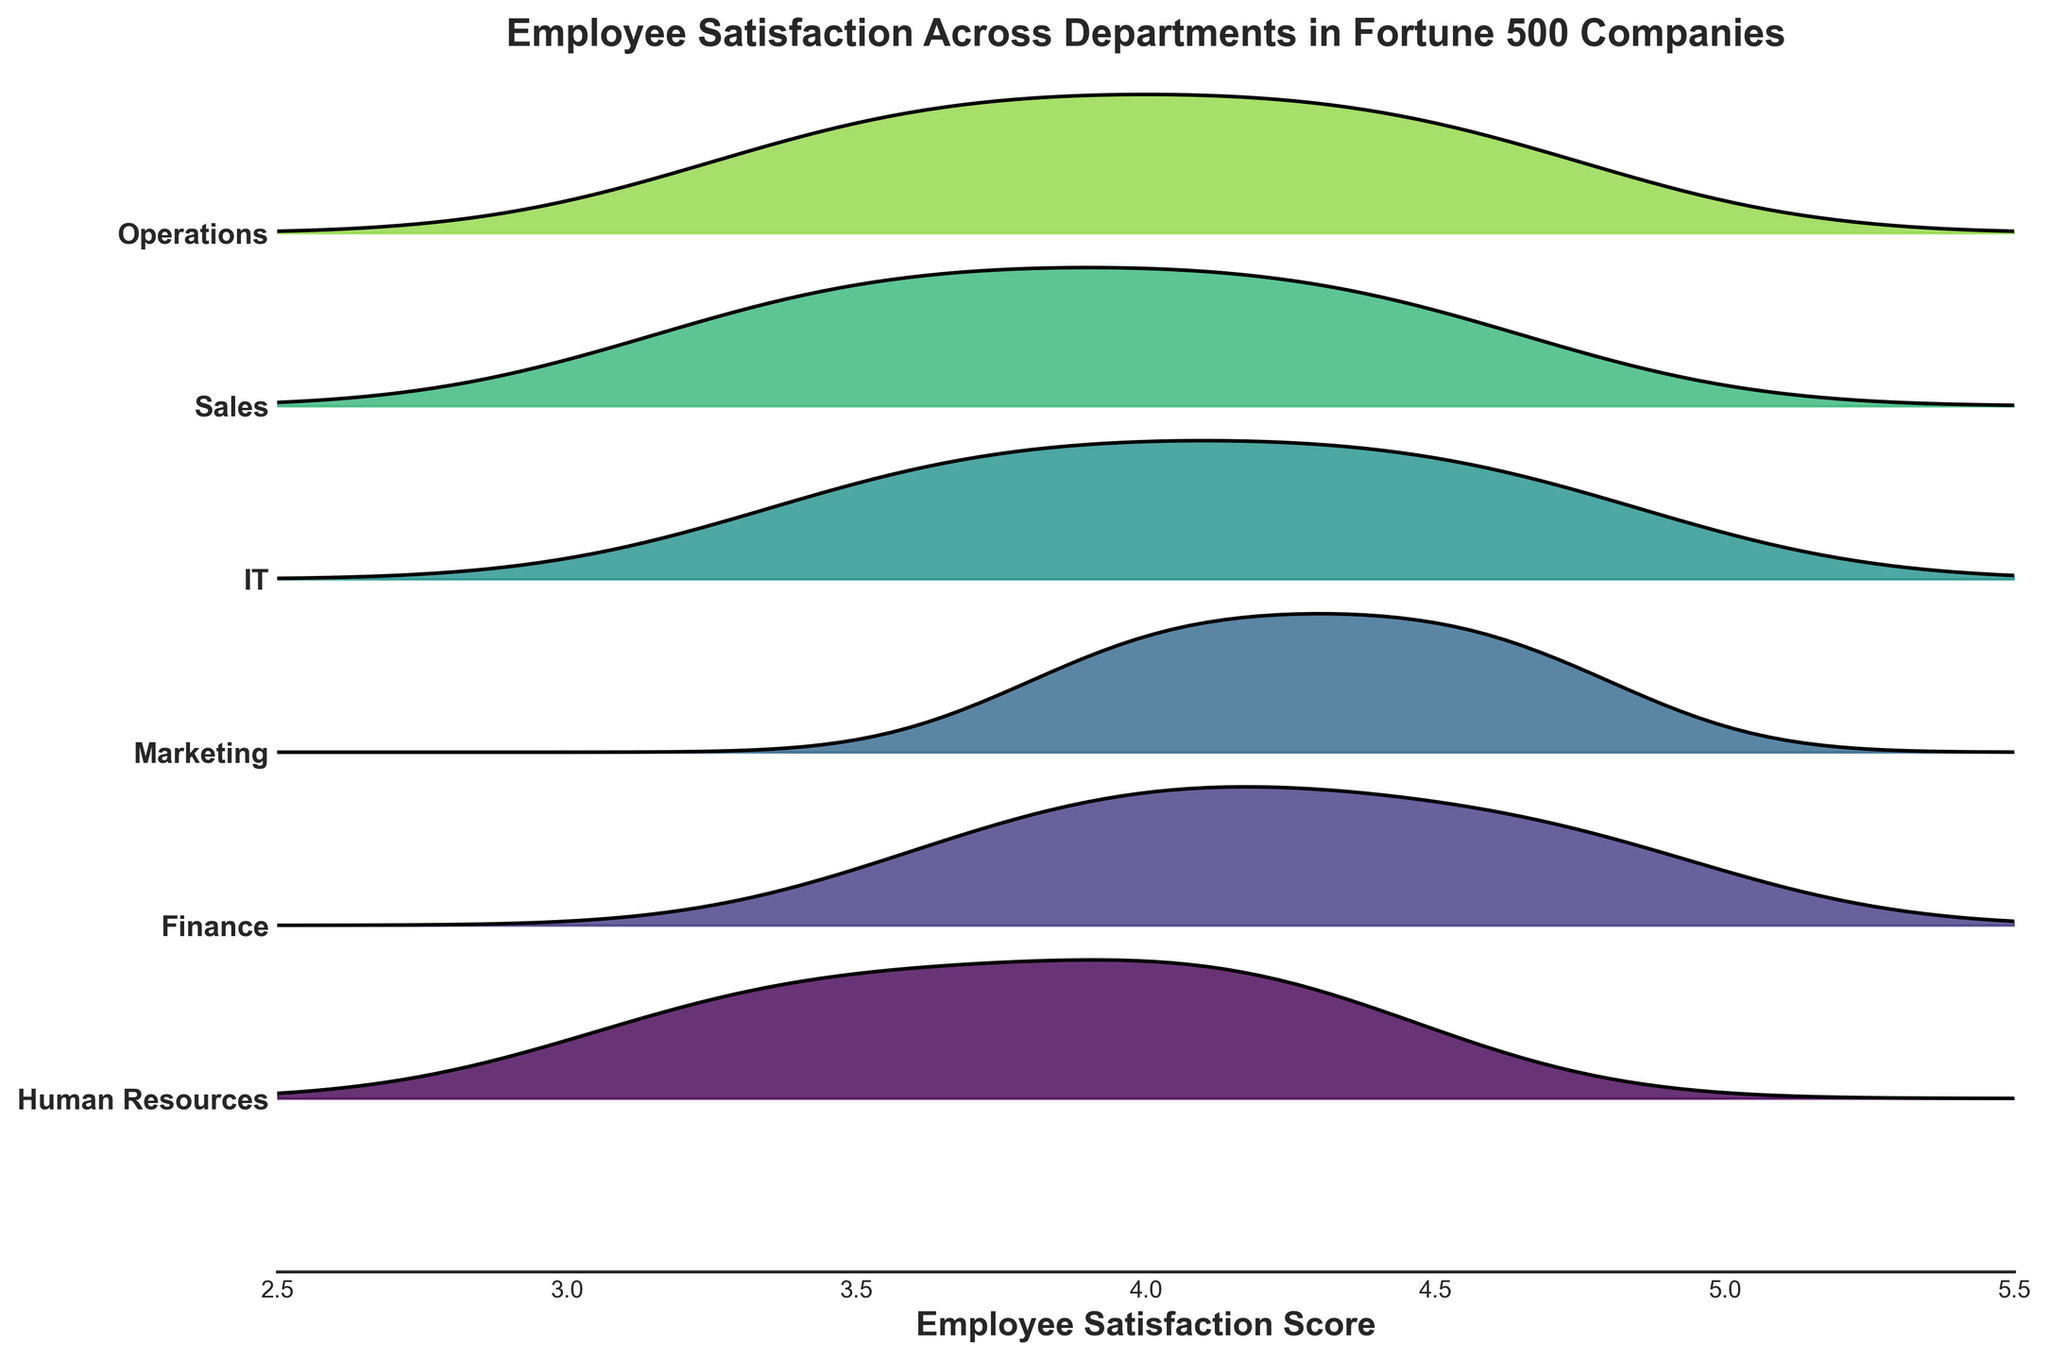Which department has the widest range of employee satisfaction scores? By examining the width of the kernel density estimates for each department, we can see which range spans the most. The widest range is a larger spread across the x-axis.
Answer: Operations What is the title of the figure? The title is usually placed at the top of the figure. In this case, it is clearly visible and indicates the main topic of the figure.
Answer: Employee Satisfaction Across Departments in Fortune 500 Companies Which department shows the highest peak in the Ridgeline plot? The highest peak indicates the maximum density, which can be seen by identifying the tallest point across the y-axis.
Answer: Marketing Does the Operations department have any scores below 3.0? The x-axis ranges from 2.5 to 5.5. By visually inspecting the Operations department's distribution, we can see if it extends below 3.0.
Answer: No Which department shows the narrowest range of satisfaction scores? The narrowest range can be identified by looking at the department with the smallest spread across the x-axis.
Answer: Human Resources What is the x-axis labeled as in the figure? Usually, the label of the x-axis is placed horizontally below the axis. In this figure, it describes what the x-values represent.
Answer: Employee Satisfaction Score Among IT and Finance, which department has a higher median satisfaction score? By checking the central tendency of the density plot for both IT and Finance, we can determine which department's median is higher.
Answer: Finance Which color represents the Human Resources department in the Ridgeline plot? Each department likely has a distinct color. By identifying the specific department labeled "Human Resources," we can associate it with its color.
Answer: A shade of green (assuming from Viridis) Which departments show scores with significant overlap? By observing the continuity in the overlapping sections of department distributions, we can determine which have significant overlaps.
Answer: IT and Marketing What score range does the Finance department cover? By visually tracing the distribution of densities for the Finance department, we can see the minimum and maximum scores it covers.
Answer: 3.7 to 4.8 